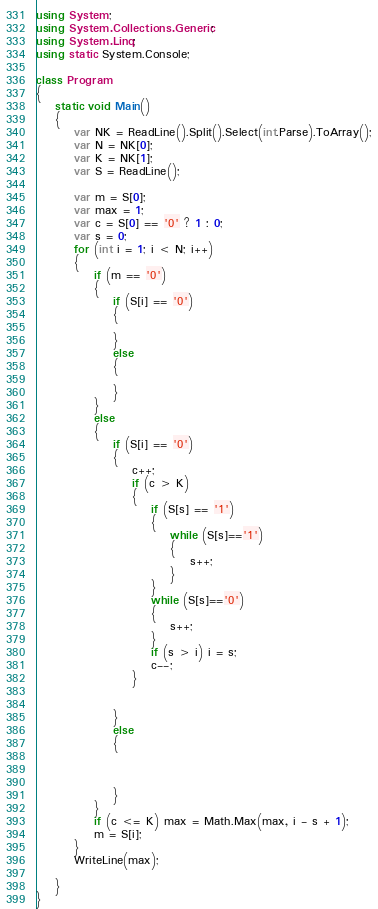<code> <loc_0><loc_0><loc_500><loc_500><_C#_>using System;
using System.Collections.Generic;
using System.Linq;
using static System.Console;

class Program
{
    static void Main()
    {
        var NK = ReadLine().Split().Select(int.Parse).ToArray();
        var N = NK[0];
        var K = NK[1];
        var S = ReadLine();

        var m = S[0];
        var max = 1;
        var c = S[0] == '0' ? 1 : 0;
        var s = 0;
        for (int i = 1; i < N; i++)
        {
            if (m == '0')
            {
                if (S[i] == '0')
                {

                }
                else
                {

                }
            }
            else
            {
                if (S[i] == '0')
                {
                    c++;
                    if (c > K)
                    {
                        if (S[s] == '1')
                        {
                            while (S[s]=='1')
                            {
                                s++;
                            }
                        }
                        while (S[s]=='0')
                        {
                            s++;
                        }
                        if (s > i) i = s;
                        c--;
                    }
                    

                }
                else
                {
                    


                }
            }
            if (c <= K) max = Math.Max(max, i - s + 1);
            m = S[i];
        }
        WriteLine(max);

    }
}
</code> 